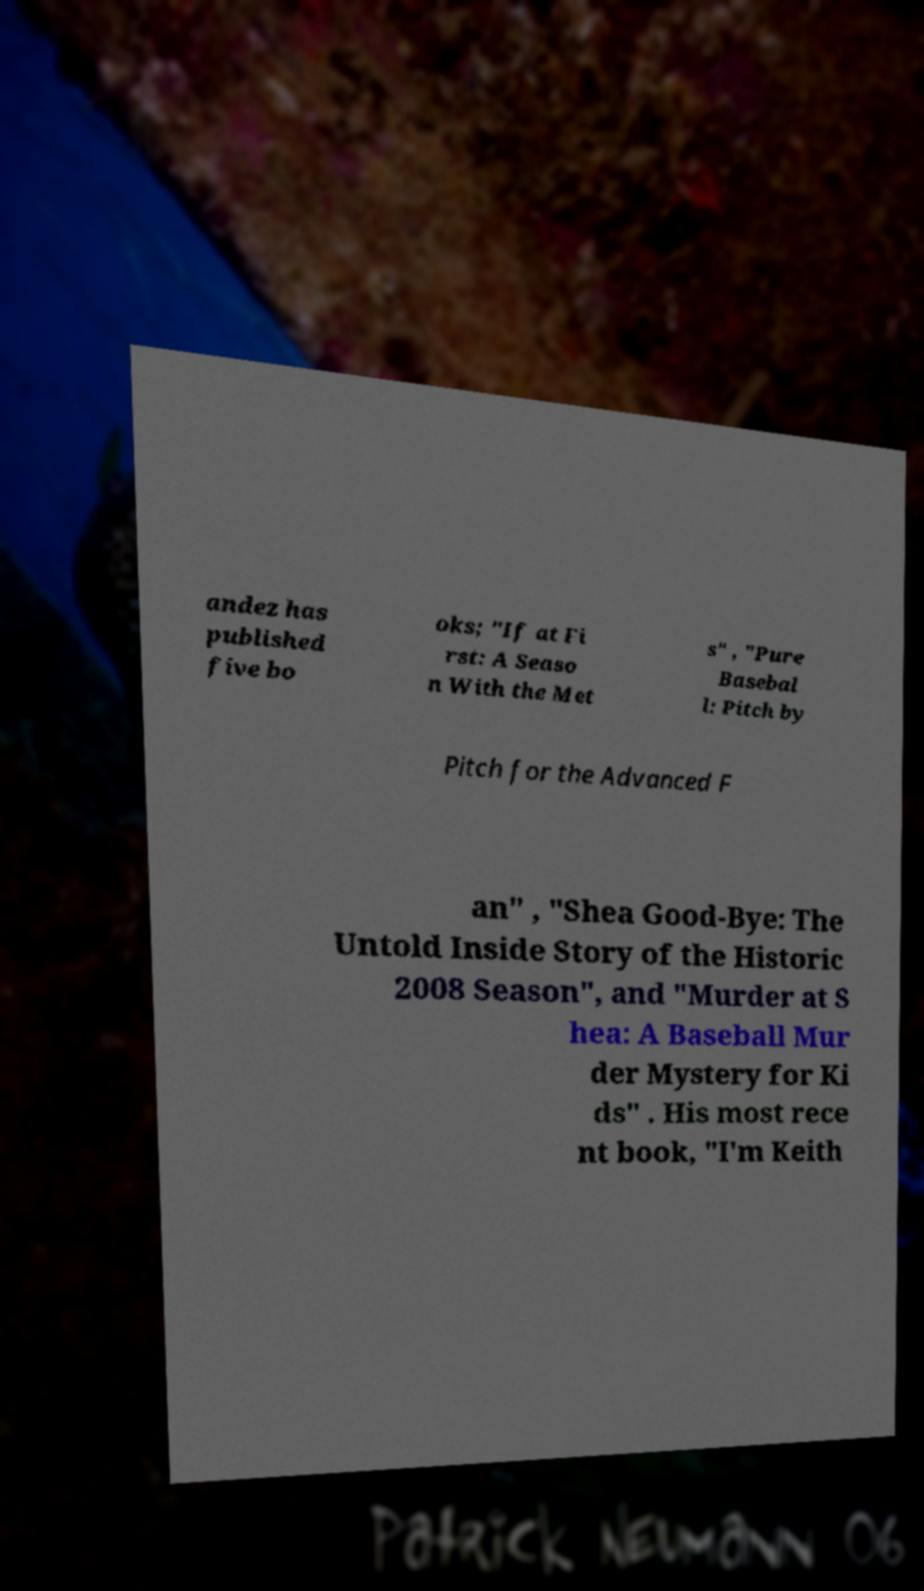Can you read and provide the text displayed in the image?This photo seems to have some interesting text. Can you extract and type it out for me? andez has published five bo oks; "If at Fi rst: A Seaso n With the Met s" , "Pure Basebal l: Pitch by Pitch for the Advanced F an" , "Shea Good-Bye: The Untold Inside Story of the Historic 2008 Season", and "Murder at S hea: A Baseball Mur der Mystery for Ki ds" . His most rece nt book, "I'm Keith 